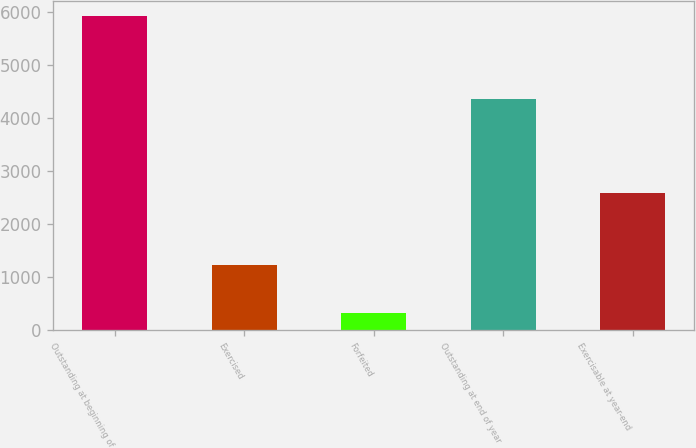Convert chart to OTSL. <chart><loc_0><loc_0><loc_500><loc_500><bar_chart><fcel>Outstanding at beginning of<fcel>Exercised<fcel>Forfeited<fcel>Outstanding at end of year<fcel>Exercisable at year-end<nl><fcel>5914<fcel>1236<fcel>331<fcel>4347<fcel>2588<nl></chart> 